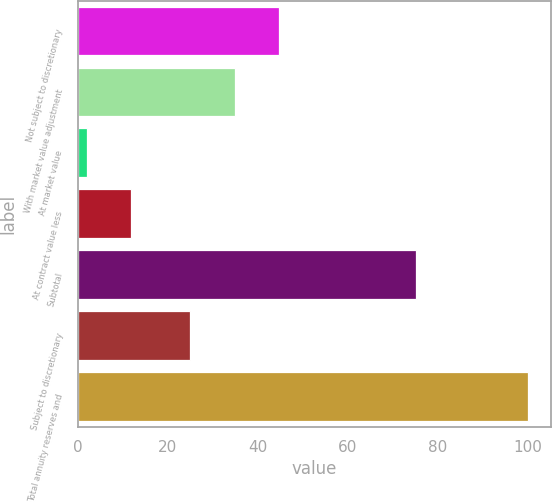Convert chart. <chart><loc_0><loc_0><loc_500><loc_500><bar_chart><fcel>Not subject to discretionary<fcel>With market value adjustment<fcel>At market value<fcel>At contract value less<fcel>Subtotal<fcel>Subject to discretionary<fcel>Total annuity reserves and<nl><fcel>44.6<fcel>34.8<fcel>2<fcel>11.8<fcel>75<fcel>25<fcel>100<nl></chart> 